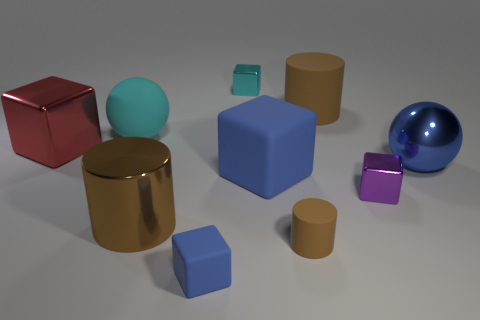Subtract all purple cubes. How many cubes are left? 4 Subtract all small rubber cubes. How many cubes are left? 4 Subtract all purple cylinders. Subtract all red balls. How many cylinders are left? 3 Subtract all balls. How many objects are left? 8 Add 8 purple shiny objects. How many purple shiny objects exist? 9 Subtract 0 gray blocks. How many objects are left? 10 Subtract all tiny blue cylinders. Subtract all tiny matte blocks. How many objects are left? 9 Add 8 cyan matte objects. How many cyan matte objects are left? 9 